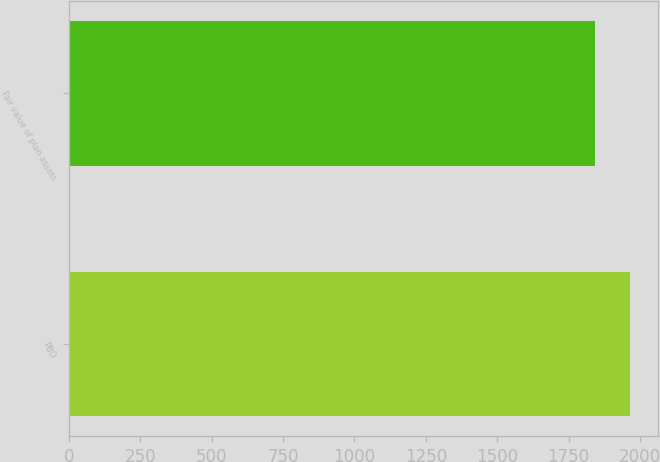<chart> <loc_0><loc_0><loc_500><loc_500><bar_chart><fcel>PBO<fcel>Fair value of plan assets<nl><fcel>1964<fcel>1842<nl></chart> 